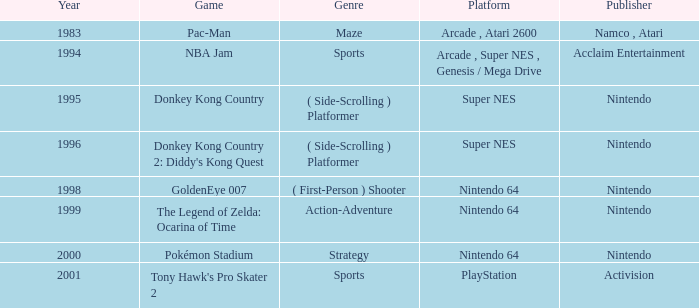Which Genre has a Game of tony hawk's pro skater 2? Sports. Write the full table. {'header': ['Year', 'Game', 'Genre', 'Platform', 'Publisher'], 'rows': [['1983', 'Pac-Man', 'Maze', 'Arcade , Atari 2600', 'Namco , Atari'], ['1994', 'NBA Jam', 'Sports', 'Arcade , Super NES , Genesis / Mega Drive', 'Acclaim Entertainment'], ['1995', 'Donkey Kong Country', '( Side-Scrolling ) Platformer', 'Super NES', 'Nintendo'], ['1996', "Donkey Kong Country 2: Diddy's Kong Quest", '( Side-Scrolling ) Platformer', 'Super NES', 'Nintendo'], ['1998', 'GoldenEye 007', '( First-Person ) Shooter', 'Nintendo 64', 'Nintendo'], ['1999', 'The Legend of Zelda: Ocarina of Time', 'Action-Adventure', 'Nintendo 64', 'Nintendo'], ['2000', 'Pokémon Stadium', 'Strategy', 'Nintendo 64', 'Nintendo'], ['2001', "Tony Hawk's Pro Skater 2", 'Sports', 'PlayStation', 'Activision']]} 